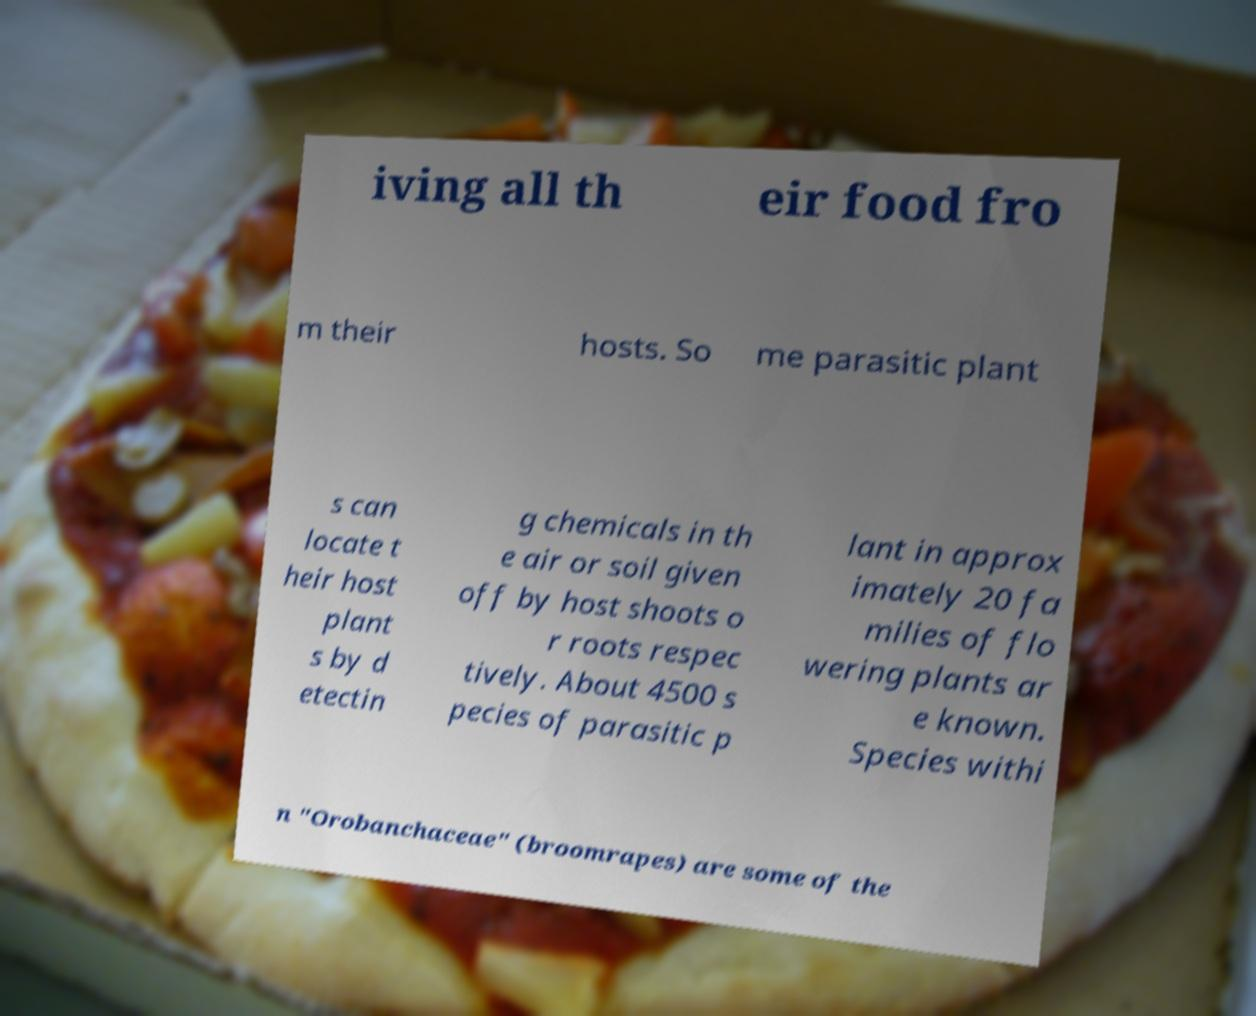I need the written content from this picture converted into text. Can you do that? iving all th eir food fro m their hosts. So me parasitic plant s can locate t heir host plant s by d etectin g chemicals in th e air or soil given off by host shoots o r roots respec tively. About 4500 s pecies of parasitic p lant in approx imately 20 fa milies of flo wering plants ar e known. Species withi n "Orobanchaceae" (broomrapes) are some of the 